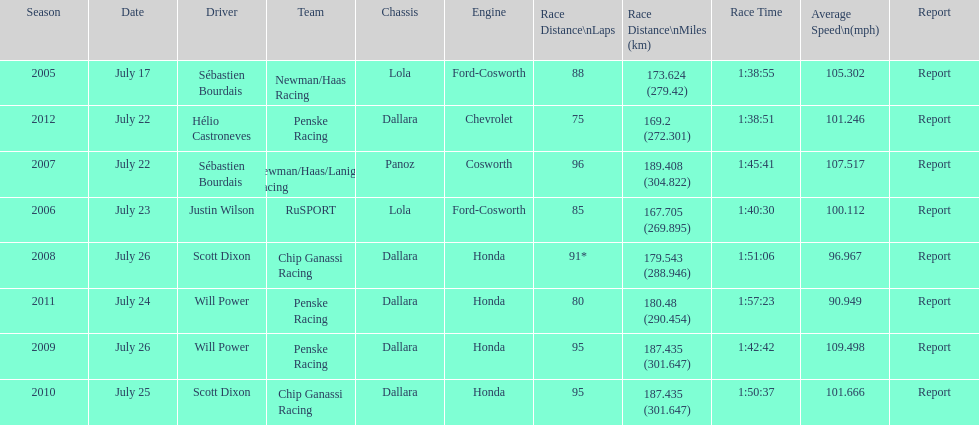How many total honda engines were there? 4. 